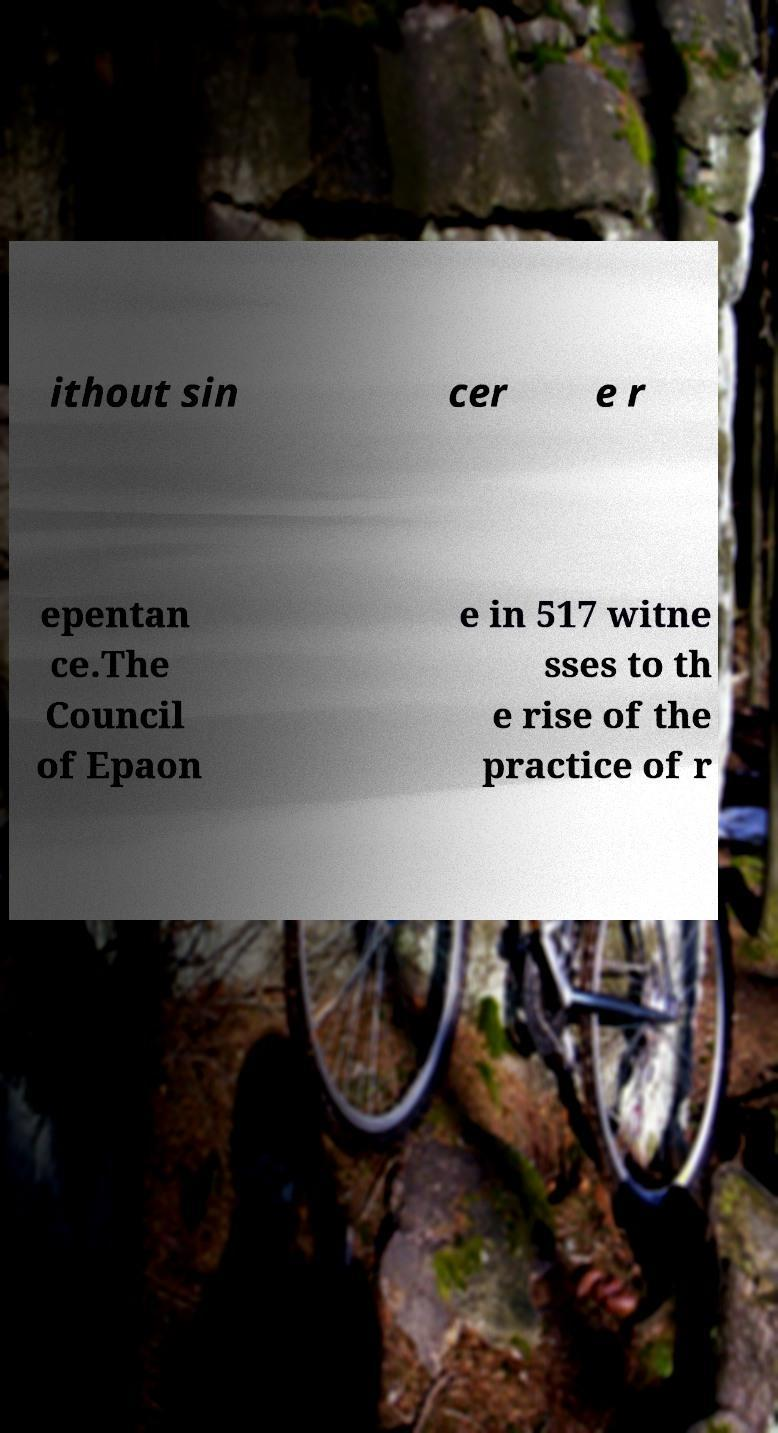There's text embedded in this image that I need extracted. Can you transcribe it verbatim? ithout sin cer e r epentan ce.The Council of Epaon e in 517 witne sses to th e rise of the practice of r 